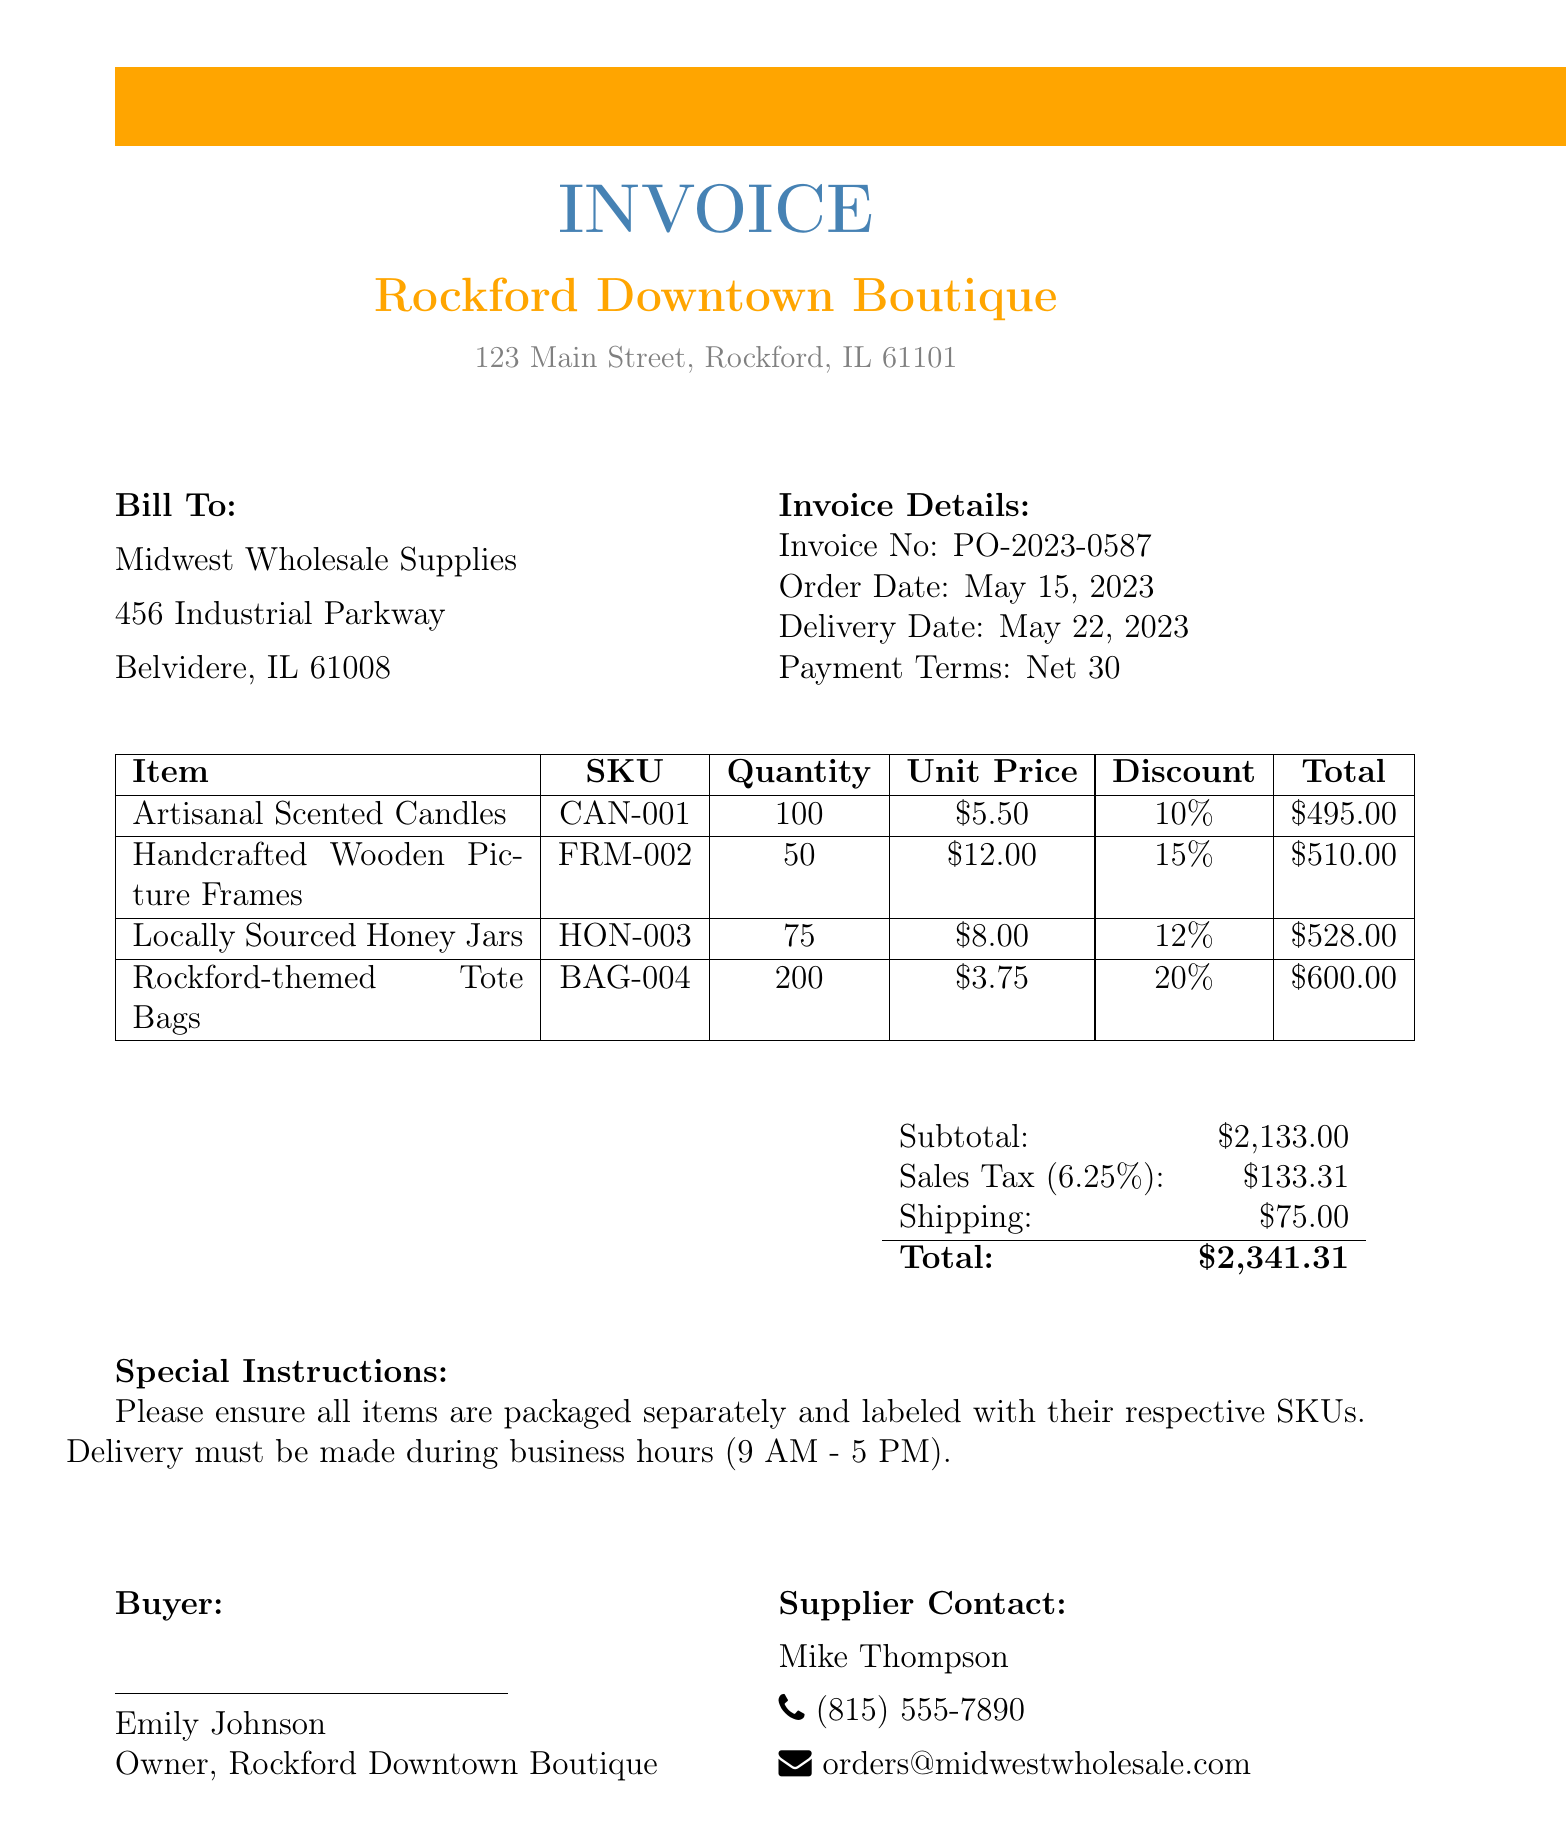What is the business name? The document states the business name at the top, which is Rockford Downtown Boutique.
Answer: Rockford Downtown Boutique Who is the supplier? The supplier information is provided in the document, indicating the name as Midwest Wholesale Supplies.
Answer: Midwest Wholesale Supplies What is the purchase order number? The invoice details section includes the purchase order number as PO-2023-0587.
Answer: PO-2023-0587 What is the total amount due? The document specifies the total amount due at the bottom, which is $2,341.31.
Answer: $2,341.31 How many Artisanal Scented Candles were purchased? The itemized list shows a quantity of 100 for Artisanal Scented Candles.
Answer: 100 What is the shipping cost? The shipping cost is mentioned in the summary section of the document as $75.00.
Answer: $75.00 What is the sales tax rate? The sales tax rate is indicated in the document as 6.25%.
Answer: 6.25% What is the date of delivery? The invoice details provide the delivery date as May 22, 2023.
Answer: May 22, 2023 What are special instructions for delivery? Special instructions indicate that items should be packaged separately and labeled with SKUs, with delivery during business hours.
Answer: Please ensure all items are packaged separately and labeled with their respective SKUs. Delivery must be made during business hours (9 AM - 5 PM) 